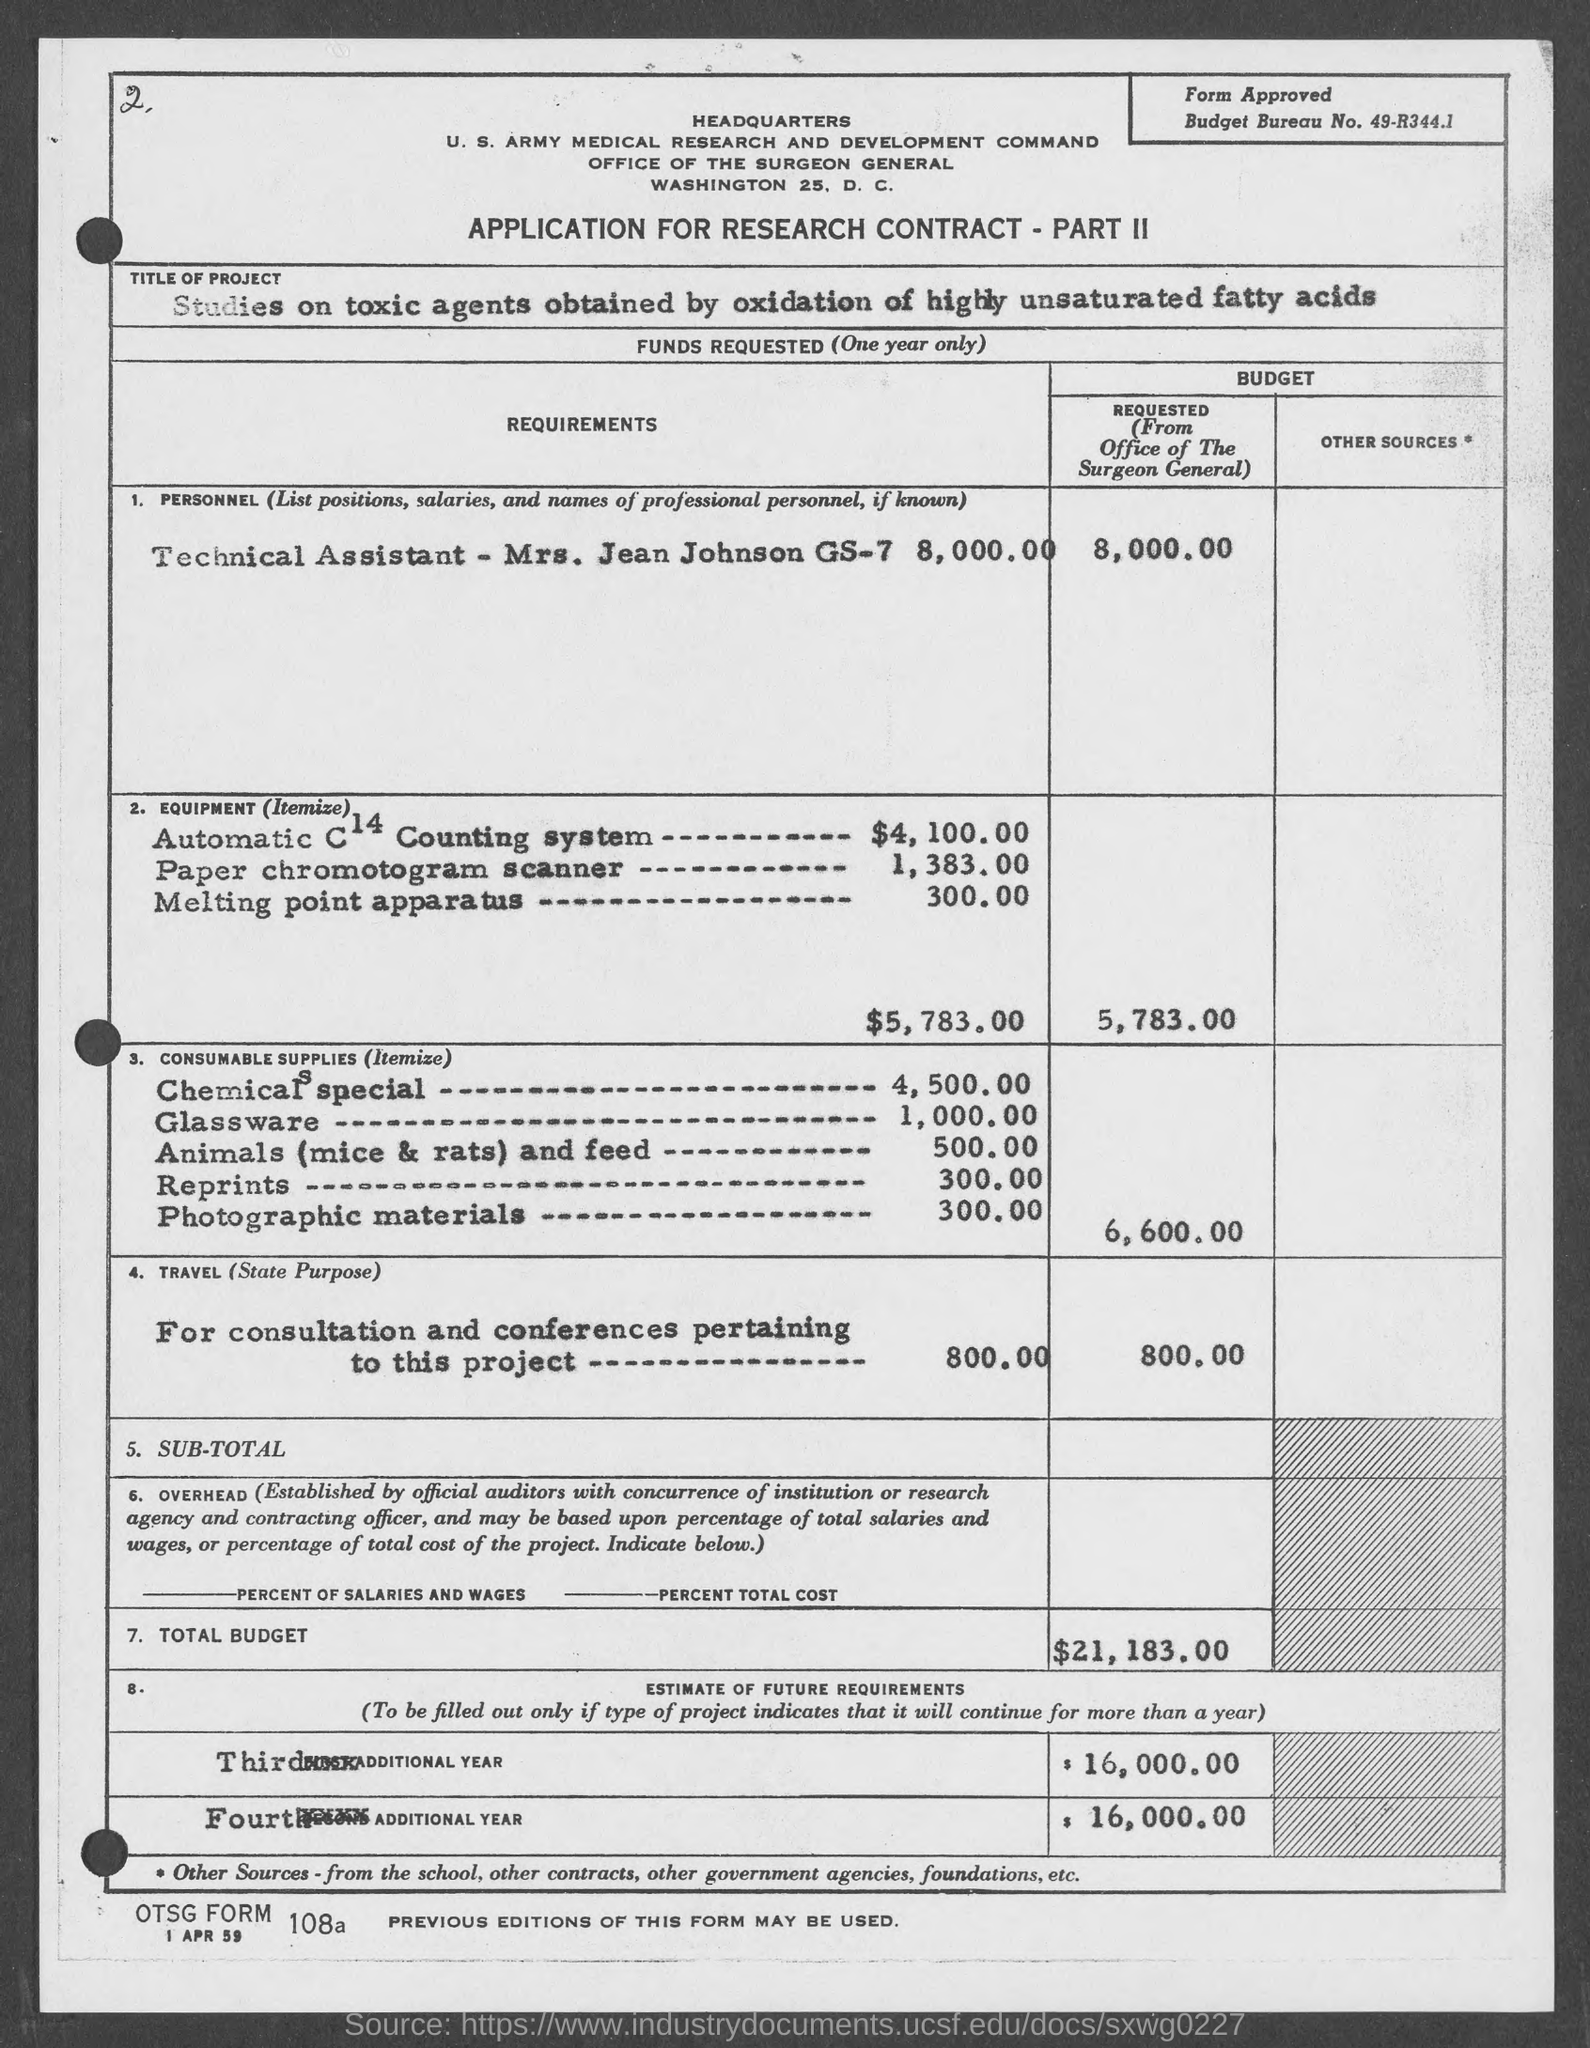List a handful of essential elements in this visual. The estimated future requirements for the third and fourth additional year are $16,000.00. The requested budget for consumable supplies is $6,600.00. The total budget requested is $21,183.00. The title of this project is 'Studies on Toxic Agents Obtained by Oxidation of Highly Unsaturated Fatty Acids.' The name of the technical assistant is Mrs. Jean Johnson. 